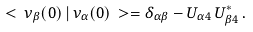<formula> <loc_0><loc_0><loc_500><loc_500>< \, \nu _ { \beta } ( 0 ) \, | \, \nu _ { \alpha } ( 0 ) \, > = \delta _ { \alpha \beta } - U _ { \alpha 4 } \, U _ { \beta 4 } ^ { * } \, .</formula> 